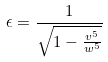Convert formula to latex. <formula><loc_0><loc_0><loc_500><loc_500>\epsilon = \frac { 1 } { \sqrt { 1 - \frac { v ^ { 5 } } { w ^ { 5 } } } }</formula> 